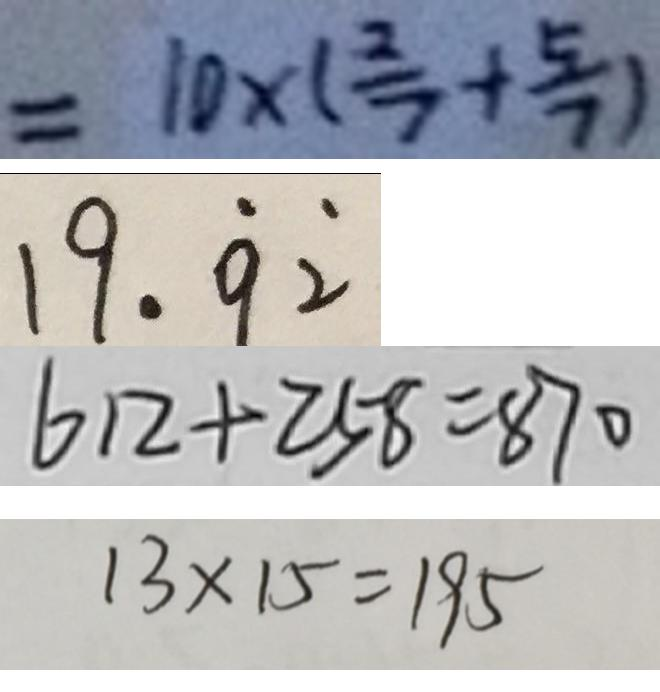Convert formula to latex. <formula><loc_0><loc_0><loc_500><loc_500>= 1 0 \times ( \frac { 2 } { 7 } + \frac { 5 } { 7 } ) 
 1 9 . \dot { 9 } \dot { 2 } 
 6 1 2 + 2 5 8 = 8 7 0 
 1 3 \times 1 5 = 1 9 5</formula> 